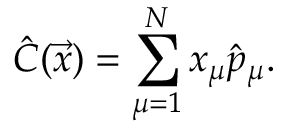Convert formula to latex. <formula><loc_0><loc_0><loc_500><loc_500>\hat { C } ( \vec { x } ) = \sum _ { \mu = 1 } ^ { N } x _ { \mu } \hat { p } _ { \mu } .</formula> 